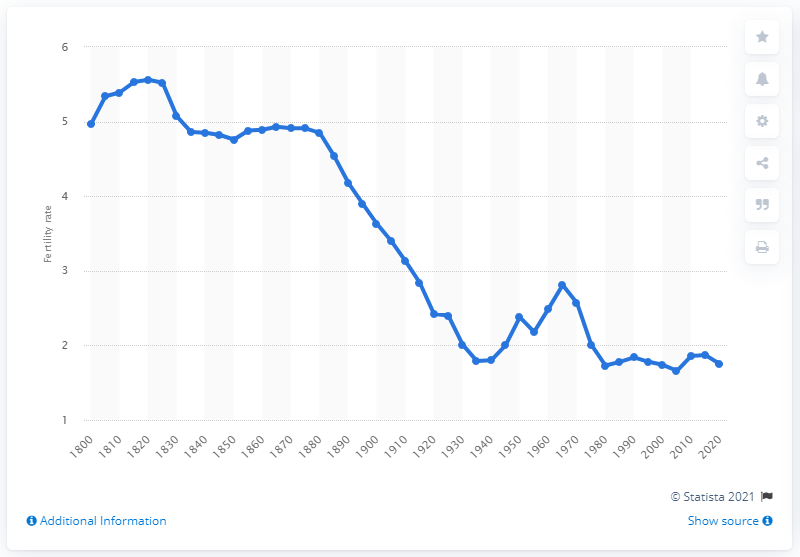Indicate a few pertinent items in this graphic. The fertility rate plateaued in the year 1880. 